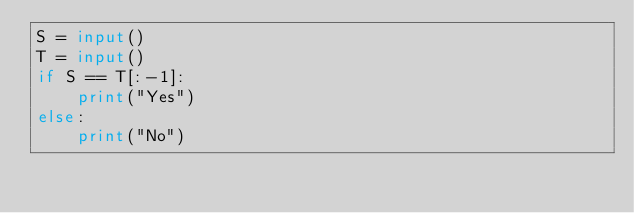Convert code to text. <code><loc_0><loc_0><loc_500><loc_500><_Python_>S = input()
T = input()
if S == T[:-1]:
    print("Yes")
else:
    print("No")
    </code> 